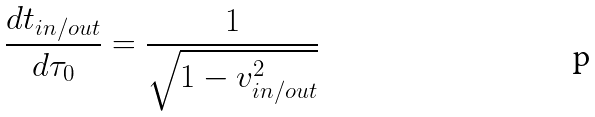Convert formula to latex. <formula><loc_0><loc_0><loc_500><loc_500>\frac { d t _ { i n / o u t } } { d \tau _ { 0 } } = \frac { 1 } { \sqrt { 1 - v _ { i n / o u t } ^ { 2 } } }</formula> 